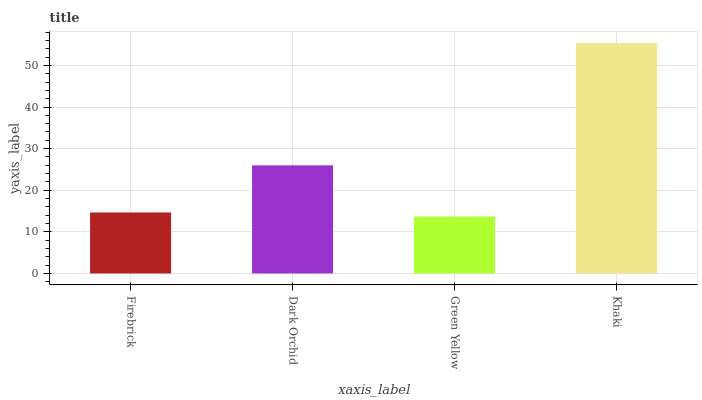Is Green Yellow the minimum?
Answer yes or no. Yes. Is Khaki the maximum?
Answer yes or no. Yes. Is Dark Orchid the minimum?
Answer yes or no. No. Is Dark Orchid the maximum?
Answer yes or no. No. Is Dark Orchid greater than Firebrick?
Answer yes or no. Yes. Is Firebrick less than Dark Orchid?
Answer yes or no. Yes. Is Firebrick greater than Dark Orchid?
Answer yes or no. No. Is Dark Orchid less than Firebrick?
Answer yes or no. No. Is Dark Orchid the high median?
Answer yes or no. Yes. Is Firebrick the low median?
Answer yes or no. Yes. Is Firebrick the high median?
Answer yes or no. No. Is Green Yellow the low median?
Answer yes or no. No. 